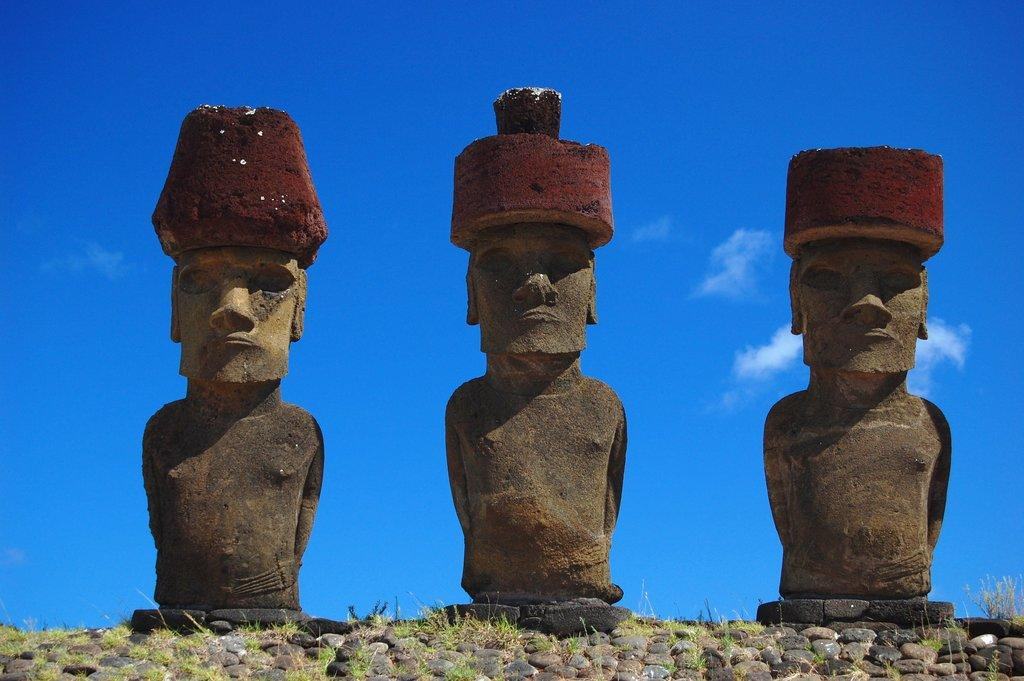How many sculptures can be seen in the image? There are three sculptures in the image. Where are the sculptures located? The sculptures are on rocks and grass. What can be seen in the background of the image? The sky is visible in the image. What type of texture can be seen on the farm in the image? There is no farm present in the image, and therefore no texture can be observed. How many ants are visible on the sculptures in the image? There are no ants present on the sculptures in the image. 